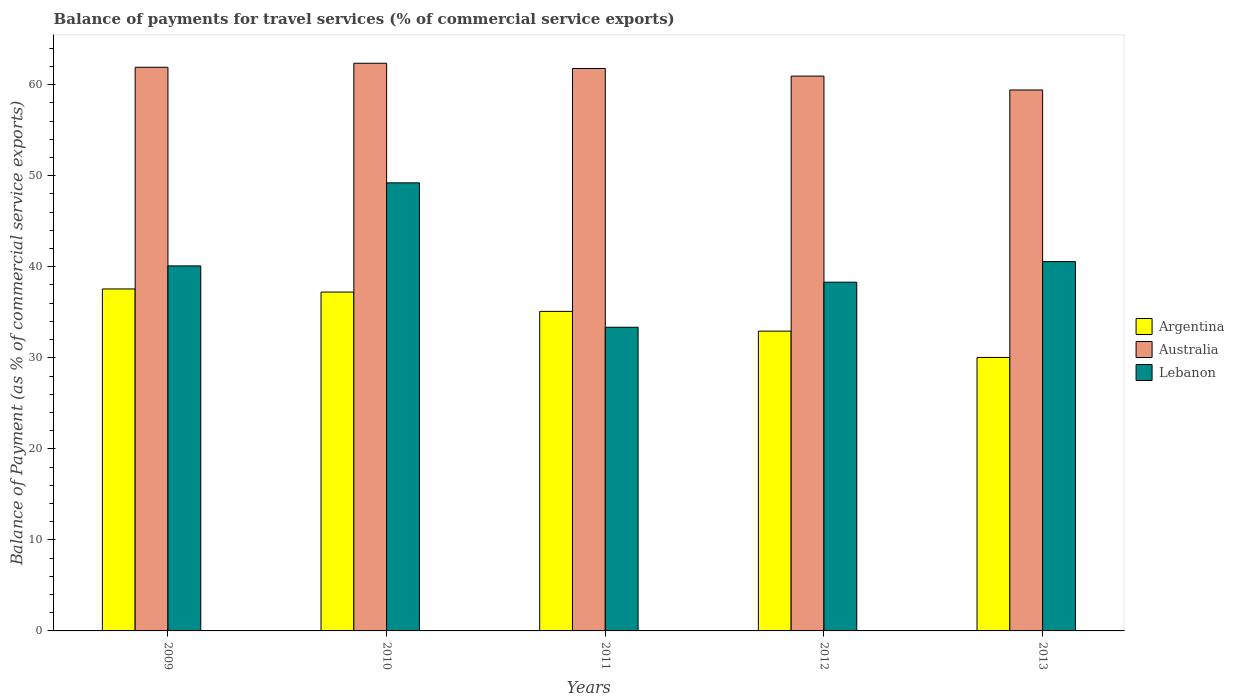How many different coloured bars are there?
Ensure brevity in your answer.  3. What is the label of the 2nd group of bars from the left?
Ensure brevity in your answer.  2010. What is the balance of payments for travel services in Argentina in 2009?
Ensure brevity in your answer.  37.56. Across all years, what is the maximum balance of payments for travel services in Lebanon?
Your response must be concise. 49.22. Across all years, what is the minimum balance of payments for travel services in Lebanon?
Your answer should be compact. 33.36. In which year was the balance of payments for travel services in Australia maximum?
Your response must be concise. 2010. In which year was the balance of payments for travel services in Australia minimum?
Your response must be concise. 2013. What is the total balance of payments for travel services in Lebanon in the graph?
Make the answer very short. 201.54. What is the difference between the balance of payments for travel services in Australia in 2012 and that in 2013?
Your response must be concise. 1.52. What is the difference between the balance of payments for travel services in Lebanon in 2012 and the balance of payments for travel services in Argentina in 2013?
Your response must be concise. 8.27. What is the average balance of payments for travel services in Argentina per year?
Your answer should be compact. 34.57. In the year 2009, what is the difference between the balance of payments for travel services in Lebanon and balance of payments for travel services in Argentina?
Give a very brief answer. 2.53. In how many years, is the balance of payments for travel services in Argentina greater than 48 %?
Provide a succinct answer. 0. What is the ratio of the balance of payments for travel services in Lebanon in 2009 to that in 2011?
Make the answer very short. 1.2. Is the balance of payments for travel services in Argentina in 2009 less than that in 2013?
Give a very brief answer. No. What is the difference between the highest and the second highest balance of payments for travel services in Lebanon?
Your answer should be very brief. 8.65. What is the difference between the highest and the lowest balance of payments for travel services in Australia?
Keep it short and to the point. 2.93. In how many years, is the balance of payments for travel services in Lebanon greater than the average balance of payments for travel services in Lebanon taken over all years?
Offer a very short reply. 2. What does the 3rd bar from the left in 2009 represents?
Your answer should be compact. Lebanon. What does the 3rd bar from the right in 2013 represents?
Ensure brevity in your answer.  Argentina. Is it the case that in every year, the sum of the balance of payments for travel services in Lebanon and balance of payments for travel services in Argentina is greater than the balance of payments for travel services in Australia?
Provide a short and direct response. Yes. How many bars are there?
Provide a short and direct response. 15. Are all the bars in the graph horizontal?
Your answer should be compact. No. How many years are there in the graph?
Offer a terse response. 5. Does the graph contain any zero values?
Your response must be concise. No. What is the title of the graph?
Provide a short and direct response. Balance of payments for travel services (% of commercial service exports). What is the label or title of the X-axis?
Keep it short and to the point. Years. What is the label or title of the Y-axis?
Ensure brevity in your answer.  Balance of Payment (as % of commercial service exports). What is the Balance of Payment (as % of commercial service exports) in Argentina in 2009?
Your response must be concise. 37.56. What is the Balance of Payment (as % of commercial service exports) in Australia in 2009?
Keep it short and to the point. 61.91. What is the Balance of Payment (as % of commercial service exports) in Lebanon in 2009?
Give a very brief answer. 40.09. What is the Balance of Payment (as % of commercial service exports) of Argentina in 2010?
Ensure brevity in your answer.  37.22. What is the Balance of Payment (as % of commercial service exports) in Australia in 2010?
Your answer should be compact. 62.35. What is the Balance of Payment (as % of commercial service exports) in Lebanon in 2010?
Your answer should be compact. 49.22. What is the Balance of Payment (as % of commercial service exports) of Argentina in 2011?
Your answer should be very brief. 35.1. What is the Balance of Payment (as % of commercial service exports) in Australia in 2011?
Keep it short and to the point. 61.78. What is the Balance of Payment (as % of commercial service exports) in Lebanon in 2011?
Your response must be concise. 33.36. What is the Balance of Payment (as % of commercial service exports) of Argentina in 2012?
Give a very brief answer. 32.93. What is the Balance of Payment (as % of commercial service exports) of Australia in 2012?
Give a very brief answer. 60.94. What is the Balance of Payment (as % of commercial service exports) in Lebanon in 2012?
Your answer should be very brief. 38.31. What is the Balance of Payment (as % of commercial service exports) of Argentina in 2013?
Your answer should be very brief. 30.04. What is the Balance of Payment (as % of commercial service exports) in Australia in 2013?
Your answer should be very brief. 59.42. What is the Balance of Payment (as % of commercial service exports) in Lebanon in 2013?
Offer a terse response. 40.57. Across all years, what is the maximum Balance of Payment (as % of commercial service exports) in Argentina?
Keep it short and to the point. 37.56. Across all years, what is the maximum Balance of Payment (as % of commercial service exports) in Australia?
Offer a terse response. 62.35. Across all years, what is the maximum Balance of Payment (as % of commercial service exports) in Lebanon?
Offer a very short reply. 49.22. Across all years, what is the minimum Balance of Payment (as % of commercial service exports) in Argentina?
Your answer should be very brief. 30.04. Across all years, what is the minimum Balance of Payment (as % of commercial service exports) in Australia?
Your answer should be very brief. 59.42. Across all years, what is the minimum Balance of Payment (as % of commercial service exports) of Lebanon?
Your response must be concise. 33.36. What is the total Balance of Payment (as % of commercial service exports) in Argentina in the graph?
Your answer should be very brief. 172.85. What is the total Balance of Payment (as % of commercial service exports) in Australia in the graph?
Give a very brief answer. 306.4. What is the total Balance of Payment (as % of commercial service exports) of Lebanon in the graph?
Offer a terse response. 201.54. What is the difference between the Balance of Payment (as % of commercial service exports) in Argentina in 2009 and that in 2010?
Keep it short and to the point. 0.34. What is the difference between the Balance of Payment (as % of commercial service exports) in Australia in 2009 and that in 2010?
Make the answer very short. -0.44. What is the difference between the Balance of Payment (as % of commercial service exports) of Lebanon in 2009 and that in 2010?
Your answer should be compact. -9.12. What is the difference between the Balance of Payment (as % of commercial service exports) in Argentina in 2009 and that in 2011?
Ensure brevity in your answer.  2.46. What is the difference between the Balance of Payment (as % of commercial service exports) in Australia in 2009 and that in 2011?
Provide a short and direct response. 0.13. What is the difference between the Balance of Payment (as % of commercial service exports) of Lebanon in 2009 and that in 2011?
Provide a succinct answer. 6.74. What is the difference between the Balance of Payment (as % of commercial service exports) in Argentina in 2009 and that in 2012?
Offer a terse response. 4.63. What is the difference between the Balance of Payment (as % of commercial service exports) of Australia in 2009 and that in 2012?
Your response must be concise. 0.97. What is the difference between the Balance of Payment (as % of commercial service exports) in Lebanon in 2009 and that in 2012?
Offer a terse response. 1.79. What is the difference between the Balance of Payment (as % of commercial service exports) of Argentina in 2009 and that in 2013?
Keep it short and to the point. 7.52. What is the difference between the Balance of Payment (as % of commercial service exports) in Australia in 2009 and that in 2013?
Offer a very short reply. 2.49. What is the difference between the Balance of Payment (as % of commercial service exports) of Lebanon in 2009 and that in 2013?
Provide a succinct answer. -0.47. What is the difference between the Balance of Payment (as % of commercial service exports) in Argentina in 2010 and that in 2011?
Make the answer very short. 2.12. What is the difference between the Balance of Payment (as % of commercial service exports) of Australia in 2010 and that in 2011?
Offer a terse response. 0.57. What is the difference between the Balance of Payment (as % of commercial service exports) in Lebanon in 2010 and that in 2011?
Your answer should be compact. 15.86. What is the difference between the Balance of Payment (as % of commercial service exports) of Argentina in 2010 and that in 2012?
Provide a short and direct response. 4.29. What is the difference between the Balance of Payment (as % of commercial service exports) in Australia in 2010 and that in 2012?
Your answer should be compact. 1.41. What is the difference between the Balance of Payment (as % of commercial service exports) of Lebanon in 2010 and that in 2012?
Ensure brevity in your answer.  10.91. What is the difference between the Balance of Payment (as % of commercial service exports) in Argentina in 2010 and that in 2013?
Provide a succinct answer. 7.18. What is the difference between the Balance of Payment (as % of commercial service exports) in Australia in 2010 and that in 2013?
Give a very brief answer. 2.93. What is the difference between the Balance of Payment (as % of commercial service exports) in Lebanon in 2010 and that in 2013?
Your answer should be compact. 8.65. What is the difference between the Balance of Payment (as % of commercial service exports) in Argentina in 2011 and that in 2012?
Give a very brief answer. 2.17. What is the difference between the Balance of Payment (as % of commercial service exports) of Australia in 2011 and that in 2012?
Provide a succinct answer. 0.84. What is the difference between the Balance of Payment (as % of commercial service exports) in Lebanon in 2011 and that in 2012?
Give a very brief answer. -4.95. What is the difference between the Balance of Payment (as % of commercial service exports) of Argentina in 2011 and that in 2013?
Your response must be concise. 5.06. What is the difference between the Balance of Payment (as % of commercial service exports) of Australia in 2011 and that in 2013?
Your answer should be very brief. 2.36. What is the difference between the Balance of Payment (as % of commercial service exports) of Lebanon in 2011 and that in 2013?
Offer a terse response. -7.21. What is the difference between the Balance of Payment (as % of commercial service exports) of Argentina in 2012 and that in 2013?
Offer a terse response. 2.89. What is the difference between the Balance of Payment (as % of commercial service exports) of Australia in 2012 and that in 2013?
Offer a very short reply. 1.52. What is the difference between the Balance of Payment (as % of commercial service exports) in Lebanon in 2012 and that in 2013?
Keep it short and to the point. -2.26. What is the difference between the Balance of Payment (as % of commercial service exports) in Argentina in 2009 and the Balance of Payment (as % of commercial service exports) in Australia in 2010?
Give a very brief answer. -24.79. What is the difference between the Balance of Payment (as % of commercial service exports) in Argentina in 2009 and the Balance of Payment (as % of commercial service exports) in Lebanon in 2010?
Offer a terse response. -11.65. What is the difference between the Balance of Payment (as % of commercial service exports) of Australia in 2009 and the Balance of Payment (as % of commercial service exports) of Lebanon in 2010?
Make the answer very short. 12.7. What is the difference between the Balance of Payment (as % of commercial service exports) in Argentina in 2009 and the Balance of Payment (as % of commercial service exports) in Australia in 2011?
Make the answer very short. -24.22. What is the difference between the Balance of Payment (as % of commercial service exports) of Argentina in 2009 and the Balance of Payment (as % of commercial service exports) of Lebanon in 2011?
Ensure brevity in your answer.  4.21. What is the difference between the Balance of Payment (as % of commercial service exports) of Australia in 2009 and the Balance of Payment (as % of commercial service exports) of Lebanon in 2011?
Ensure brevity in your answer.  28.56. What is the difference between the Balance of Payment (as % of commercial service exports) in Argentina in 2009 and the Balance of Payment (as % of commercial service exports) in Australia in 2012?
Keep it short and to the point. -23.38. What is the difference between the Balance of Payment (as % of commercial service exports) in Argentina in 2009 and the Balance of Payment (as % of commercial service exports) in Lebanon in 2012?
Give a very brief answer. -0.74. What is the difference between the Balance of Payment (as % of commercial service exports) in Australia in 2009 and the Balance of Payment (as % of commercial service exports) in Lebanon in 2012?
Your answer should be very brief. 23.61. What is the difference between the Balance of Payment (as % of commercial service exports) of Argentina in 2009 and the Balance of Payment (as % of commercial service exports) of Australia in 2013?
Provide a short and direct response. -21.86. What is the difference between the Balance of Payment (as % of commercial service exports) of Argentina in 2009 and the Balance of Payment (as % of commercial service exports) of Lebanon in 2013?
Your response must be concise. -3.01. What is the difference between the Balance of Payment (as % of commercial service exports) of Australia in 2009 and the Balance of Payment (as % of commercial service exports) of Lebanon in 2013?
Your answer should be compact. 21.34. What is the difference between the Balance of Payment (as % of commercial service exports) in Argentina in 2010 and the Balance of Payment (as % of commercial service exports) in Australia in 2011?
Make the answer very short. -24.56. What is the difference between the Balance of Payment (as % of commercial service exports) of Argentina in 2010 and the Balance of Payment (as % of commercial service exports) of Lebanon in 2011?
Your response must be concise. 3.86. What is the difference between the Balance of Payment (as % of commercial service exports) in Australia in 2010 and the Balance of Payment (as % of commercial service exports) in Lebanon in 2011?
Your answer should be very brief. 29. What is the difference between the Balance of Payment (as % of commercial service exports) of Argentina in 2010 and the Balance of Payment (as % of commercial service exports) of Australia in 2012?
Offer a very short reply. -23.72. What is the difference between the Balance of Payment (as % of commercial service exports) in Argentina in 2010 and the Balance of Payment (as % of commercial service exports) in Lebanon in 2012?
Provide a succinct answer. -1.09. What is the difference between the Balance of Payment (as % of commercial service exports) of Australia in 2010 and the Balance of Payment (as % of commercial service exports) of Lebanon in 2012?
Make the answer very short. 24.05. What is the difference between the Balance of Payment (as % of commercial service exports) in Argentina in 2010 and the Balance of Payment (as % of commercial service exports) in Australia in 2013?
Offer a terse response. -22.2. What is the difference between the Balance of Payment (as % of commercial service exports) of Argentina in 2010 and the Balance of Payment (as % of commercial service exports) of Lebanon in 2013?
Your response must be concise. -3.35. What is the difference between the Balance of Payment (as % of commercial service exports) in Australia in 2010 and the Balance of Payment (as % of commercial service exports) in Lebanon in 2013?
Your answer should be compact. 21.78. What is the difference between the Balance of Payment (as % of commercial service exports) in Argentina in 2011 and the Balance of Payment (as % of commercial service exports) in Australia in 2012?
Offer a very short reply. -25.84. What is the difference between the Balance of Payment (as % of commercial service exports) in Argentina in 2011 and the Balance of Payment (as % of commercial service exports) in Lebanon in 2012?
Make the answer very short. -3.21. What is the difference between the Balance of Payment (as % of commercial service exports) in Australia in 2011 and the Balance of Payment (as % of commercial service exports) in Lebanon in 2012?
Provide a succinct answer. 23.47. What is the difference between the Balance of Payment (as % of commercial service exports) in Argentina in 2011 and the Balance of Payment (as % of commercial service exports) in Australia in 2013?
Ensure brevity in your answer.  -24.32. What is the difference between the Balance of Payment (as % of commercial service exports) in Argentina in 2011 and the Balance of Payment (as % of commercial service exports) in Lebanon in 2013?
Ensure brevity in your answer.  -5.47. What is the difference between the Balance of Payment (as % of commercial service exports) in Australia in 2011 and the Balance of Payment (as % of commercial service exports) in Lebanon in 2013?
Your answer should be compact. 21.21. What is the difference between the Balance of Payment (as % of commercial service exports) in Argentina in 2012 and the Balance of Payment (as % of commercial service exports) in Australia in 2013?
Your answer should be very brief. -26.49. What is the difference between the Balance of Payment (as % of commercial service exports) of Argentina in 2012 and the Balance of Payment (as % of commercial service exports) of Lebanon in 2013?
Your answer should be very brief. -7.64. What is the difference between the Balance of Payment (as % of commercial service exports) in Australia in 2012 and the Balance of Payment (as % of commercial service exports) in Lebanon in 2013?
Ensure brevity in your answer.  20.37. What is the average Balance of Payment (as % of commercial service exports) in Argentina per year?
Keep it short and to the point. 34.57. What is the average Balance of Payment (as % of commercial service exports) in Australia per year?
Keep it short and to the point. 61.28. What is the average Balance of Payment (as % of commercial service exports) of Lebanon per year?
Your answer should be compact. 40.31. In the year 2009, what is the difference between the Balance of Payment (as % of commercial service exports) in Argentina and Balance of Payment (as % of commercial service exports) in Australia?
Make the answer very short. -24.35. In the year 2009, what is the difference between the Balance of Payment (as % of commercial service exports) in Argentina and Balance of Payment (as % of commercial service exports) in Lebanon?
Ensure brevity in your answer.  -2.53. In the year 2009, what is the difference between the Balance of Payment (as % of commercial service exports) of Australia and Balance of Payment (as % of commercial service exports) of Lebanon?
Keep it short and to the point. 21.82. In the year 2010, what is the difference between the Balance of Payment (as % of commercial service exports) of Argentina and Balance of Payment (as % of commercial service exports) of Australia?
Your answer should be compact. -25.13. In the year 2010, what is the difference between the Balance of Payment (as % of commercial service exports) of Argentina and Balance of Payment (as % of commercial service exports) of Lebanon?
Make the answer very short. -12. In the year 2010, what is the difference between the Balance of Payment (as % of commercial service exports) in Australia and Balance of Payment (as % of commercial service exports) in Lebanon?
Your answer should be compact. 13.14. In the year 2011, what is the difference between the Balance of Payment (as % of commercial service exports) of Argentina and Balance of Payment (as % of commercial service exports) of Australia?
Your answer should be very brief. -26.68. In the year 2011, what is the difference between the Balance of Payment (as % of commercial service exports) in Argentina and Balance of Payment (as % of commercial service exports) in Lebanon?
Make the answer very short. 1.74. In the year 2011, what is the difference between the Balance of Payment (as % of commercial service exports) in Australia and Balance of Payment (as % of commercial service exports) in Lebanon?
Your answer should be very brief. 28.42. In the year 2012, what is the difference between the Balance of Payment (as % of commercial service exports) of Argentina and Balance of Payment (as % of commercial service exports) of Australia?
Provide a short and direct response. -28.01. In the year 2012, what is the difference between the Balance of Payment (as % of commercial service exports) in Argentina and Balance of Payment (as % of commercial service exports) in Lebanon?
Keep it short and to the point. -5.37. In the year 2012, what is the difference between the Balance of Payment (as % of commercial service exports) of Australia and Balance of Payment (as % of commercial service exports) of Lebanon?
Offer a terse response. 22.64. In the year 2013, what is the difference between the Balance of Payment (as % of commercial service exports) in Argentina and Balance of Payment (as % of commercial service exports) in Australia?
Your answer should be very brief. -29.38. In the year 2013, what is the difference between the Balance of Payment (as % of commercial service exports) of Argentina and Balance of Payment (as % of commercial service exports) of Lebanon?
Provide a short and direct response. -10.53. In the year 2013, what is the difference between the Balance of Payment (as % of commercial service exports) of Australia and Balance of Payment (as % of commercial service exports) of Lebanon?
Ensure brevity in your answer.  18.85. What is the ratio of the Balance of Payment (as % of commercial service exports) in Argentina in 2009 to that in 2010?
Provide a succinct answer. 1.01. What is the ratio of the Balance of Payment (as % of commercial service exports) of Australia in 2009 to that in 2010?
Keep it short and to the point. 0.99. What is the ratio of the Balance of Payment (as % of commercial service exports) in Lebanon in 2009 to that in 2010?
Your response must be concise. 0.81. What is the ratio of the Balance of Payment (as % of commercial service exports) of Argentina in 2009 to that in 2011?
Keep it short and to the point. 1.07. What is the ratio of the Balance of Payment (as % of commercial service exports) in Australia in 2009 to that in 2011?
Provide a succinct answer. 1. What is the ratio of the Balance of Payment (as % of commercial service exports) in Lebanon in 2009 to that in 2011?
Your response must be concise. 1.2. What is the ratio of the Balance of Payment (as % of commercial service exports) in Argentina in 2009 to that in 2012?
Give a very brief answer. 1.14. What is the ratio of the Balance of Payment (as % of commercial service exports) in Australia in 2009 to that in 2012?
Provide a succinct answer. 1.02. What is the ratio of the Balance of Payment (as % of commercial service exports) of Lebanon in 2009 to that in 2012?
Offer a terse response. 1.05. What is the ratio of the Balance of Payment (as % of commercial service exports) in Argentina in 2009 to that in 2013?
Offer a terse response. 1.25. What is the ratio of the Balance of Payment (as % of commercial service exports) of Australia in 2009 to that in 2013?
Your answer should be compact. 1.04. What is the ratio of the Balance of Payment (as % of commercial service exports) of Lebanon in 2009 to that in 2013?
Offer a terse response. 0.99. What is the ratio of the Balance of Payment (as % of commercial service exports) in Argentina in 2010 to that in 2011?
Offer a terse response. 1.06. What is the ratio of the Balance of Payment (as % of commercial service exports) in Australia in 2010 to that in 2011?
Your answer should be compact. 1.01. What is the ratio of the Balance of Payment (as % of commercial service exports) in Lebanon in 2010 to that in 2011?
Keep it short and to the point. 1.48. What is the ratio of the Balance of Payment (as % of commercial service exports) in Argentina in 2010 to that in 2012?
Make the answer very short. 1.13. What is the ratio of the Balance of Payment (as % of commercial service exports) in Australia in 2010 to that in 2012?
Provide a succinct answer. 1.02. What is the ratio of the Balance of Payment (as % of commercial service exports) in Lebanon in 2010 to that in 2012?
Give a very brief answer. 1.28. What is the ratio of the Balance of Payment (as % of commercial service exports) of Argentina in 2010 to that in 2013?
Offer a terse response. 1.24. What is the ratio of the Balance of Payment (as % of commercial service exports) of Australia in 2010 to that in 2013?
Provide a short and direct response. 1.05. What is the ratio of the Balance of Payment (as % of commercial service exports) of Lebanon in 2010 to that in 2013?
Provide a succinct answer. 1.21. What is the ratio of the Balance of Payment (as % of commercial service exports) in Argentina in 2011 to that in 2012?
Provide a short and direct response. 1.07. What is the ratio of the Balance of Payment (as % of commercial service exports) in Australia in 2011 to that in 2012?
Your answer should be compact. 1.01. What is the ratio of the Balance of Payment (as % of commercial service exports) of Lebanon in 2011 to that in 2012?
Make the answer very short. 0.87. What is the ratio of the Balance of Payment (as % of commercial service exports) of Argentina in 2011 to that in 2013?
Ensure brevity in your answer.  1.17. What is the ratio of the Balance of Payment (as % of commercial service exports) in Australia in 2011 to that in 2013?
Ensure brevity in your answer.  1.04. What is the ratio of the Balance of Payment (as % of commercial service exports) of Lebanon in 2011 to that in 2013?
Offer a very short reply. 0.82. What is the ratio of the Balance of Payment (as % of commercial service exports) in Argentina in 2012 to that in 2013?
Your answer should be very brief. 1.1. What is the ratio of the Balance of Payment (as % of commercial service exports) of Australia in 2012 to that in 2013?
Provide a succinct answer. 1.03. What is the ratio of the Balance of Payment (as % of commercial service exports) of Lebanon in 2012 to that in 2013?
Your response must be concise. 0.94. What is the difference between the highest and the second highest Balance of Payment (as % of commercial service exports) in Argentina?
Make the answer very short. 0.34. What is the difference between the highest and the second highest Balance of Payment (as % of commercial service exports) in Australia?
Give a very brief answer. 0.44. What is the difference between the highest and the second highest Balance of Payment (as % of commercial service exports) of Lebanon?
Offer a terse response. 8.65. What is the difference between the highest and the lowest Balance of Payment (as % of commercial service exports) in Argentina?
Offer a very short reply. 7.52. What is the difference between the highest and the lowest Balance of Payment (as % of commercial service exports) of Australia?
Give a very brief answer. 2.93. What is the difference between the highest and the lowest Balance of Payment (as % of commercial service exports) in Lebanon?
Provide a succinct answer. 15.86. 